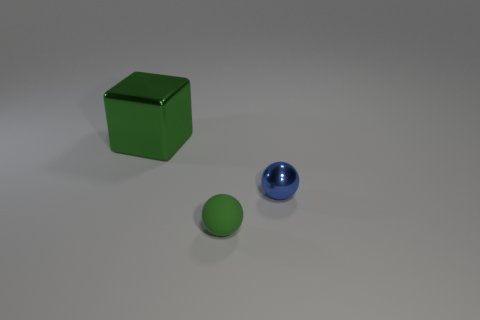Subtract 1 cubes. How many cubes are left? 0 Add 1 small brown cylinders. How many objects exist? 4 Subtract 0 red cylinders. How many objects are left? 3 Subtract all blocks. How many objects are left? 2 Subtract all yellow cubes. Subtract all gray cylinders. How many cubes are left? 1 Subtract all red blocks. How many purple spheres are left? 0 Subtract all tiny green things. Subtract all tiny blue things. How many objects are left? 1 Add 2 tiny matte spheres. How many tiny matte spheres are left? 3 Add 1 gray matte blocks. How many gray matte blocks exist? 1 Subtract all blue balls. How many balls are left? 1 